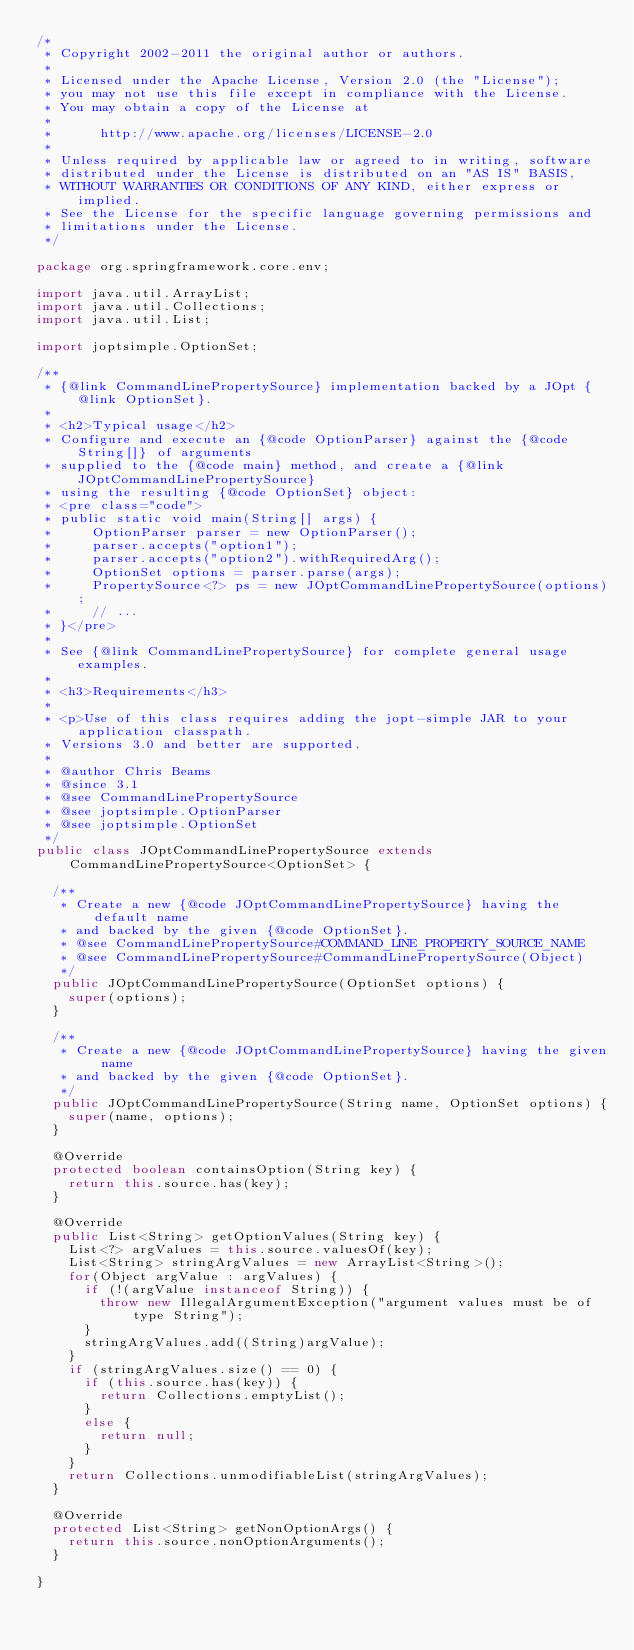<code> <loc_0><loc_0><loc_500><loc_500><_Java_>/*
 * Copyright 2002-2011 the original author or authors.
 *
 * Licensed under the Apache License, Version 2.0 (the "License");
 * you may not use this file except in compliance with the License.
 * You may obtain a copy of the License at
 *
 *      http://www.apache.org/licenses/LICENSE-2.0
 *
 * Unless required by applicable law or agreed to in writing, software
 * distributed under the License is distributed on an "AS IS" BASIS,
 * WITHOUT WARRANTIES OR CONDITIONS OF ANY KIND, either express or implied.
 * See the License for the specific language governing permissions and
 * limitations under the License.
 */

package org.springframework.core.env;

import java.util.ArrayList;
import java.util.Collections;
import java.util.List;

import joptsimple.OptionSet;

/**
 * {@link CommandLinePropertySource} implementation backed by a JOpt {@link OptionSet}.
 *
 * <h2>Typical usage</h2>
 * Configure and execute an {@code OptionParser} against the {@code String[]} of arguments
 * supplied to the {@code main} method, and create a {@link JOptCommandLinePropertySource}
 * using the resulting {@code OptionSet} object:
 * <pre class="code">
 * public static void main(String[] args) {
 *     OptionParser parser = new OptionParser();
 *     parser.accepts("option1");
 *     parser.accepts("option2").withRequiredArg();
 *     OptionSet options = parser.parse(args);
 *     PropertySource<?> ps = new JOptCommandLinePropertySource(options);
 *     // ...
 * }</pre>
 *
 * See {@link CommandLinePropertySource} for complete general usage examples.
 *
 * <h3>Requirements</h3>
 *
 * <p>Use of this class requires adding the jopt-simple JAR to your application classpath.
 * Versions 3.0 and better are supported.
 *
 * @author Chris Beams
 * @since 3.1
 * @see CommandLinePropertySource
 * @see joptsimple.OptionParser
 * @see joptsimple.OptionSet
 */
public class JOptCommandLinePropertySource extends CommandLinePropertySource<OptionSet> {

	/**
	 * Create a new {@code JOptCommandLinePropertySource} having the default name
	 * and backed by the given {@code OptionSet}.
	 * @see CommandLinePropertySource#COMMAND_LINE_PROPERTY_SOURCE_NAME
	 * @see CommandLinePropertySource#CommandLinePropertySource(Object)
	 */
	public JOptCommandLinePropertySource(OptionSet options) {
		super(options);
	}

	/**
	 * Create a new {@code JOptCommandLinePropertySource} having the given name
	 * and backed by the given {@code OptionSet}.
	 */
	public JOptCommandLinePropertySource(String name, OptionSet options) {
		super(name, options);
	}

	@Override
	protected boolean containsOption(String key) {
		return this.source.has(key);
	}

	@Override
	public List<String> getOptionValues(String key) {
		List<?> argValues = this.source.valuesOf(key);
		List<String> stringArgValues = new ArrayList<String>();
		for(Object argValue : argValues) {
			if (!(argValue instanceof String)) {
				throw new IllegalArgumentException("argument values must be of type String");
			}
			stringArgValues.add((String)argValue);
		}
		if (stringArgValues.size() == 0) {
			if (this.source.has(key)) {
				return Collections.emptyList();
			}
			else {
				return null;
			}
		}
		return Collections.unmodifiableList(stringArgValues);
	}

	@Override
	protected List<String> getNonOptionArgs() {
		return this.source.nonOptionArguments();
	}

}
</code> 